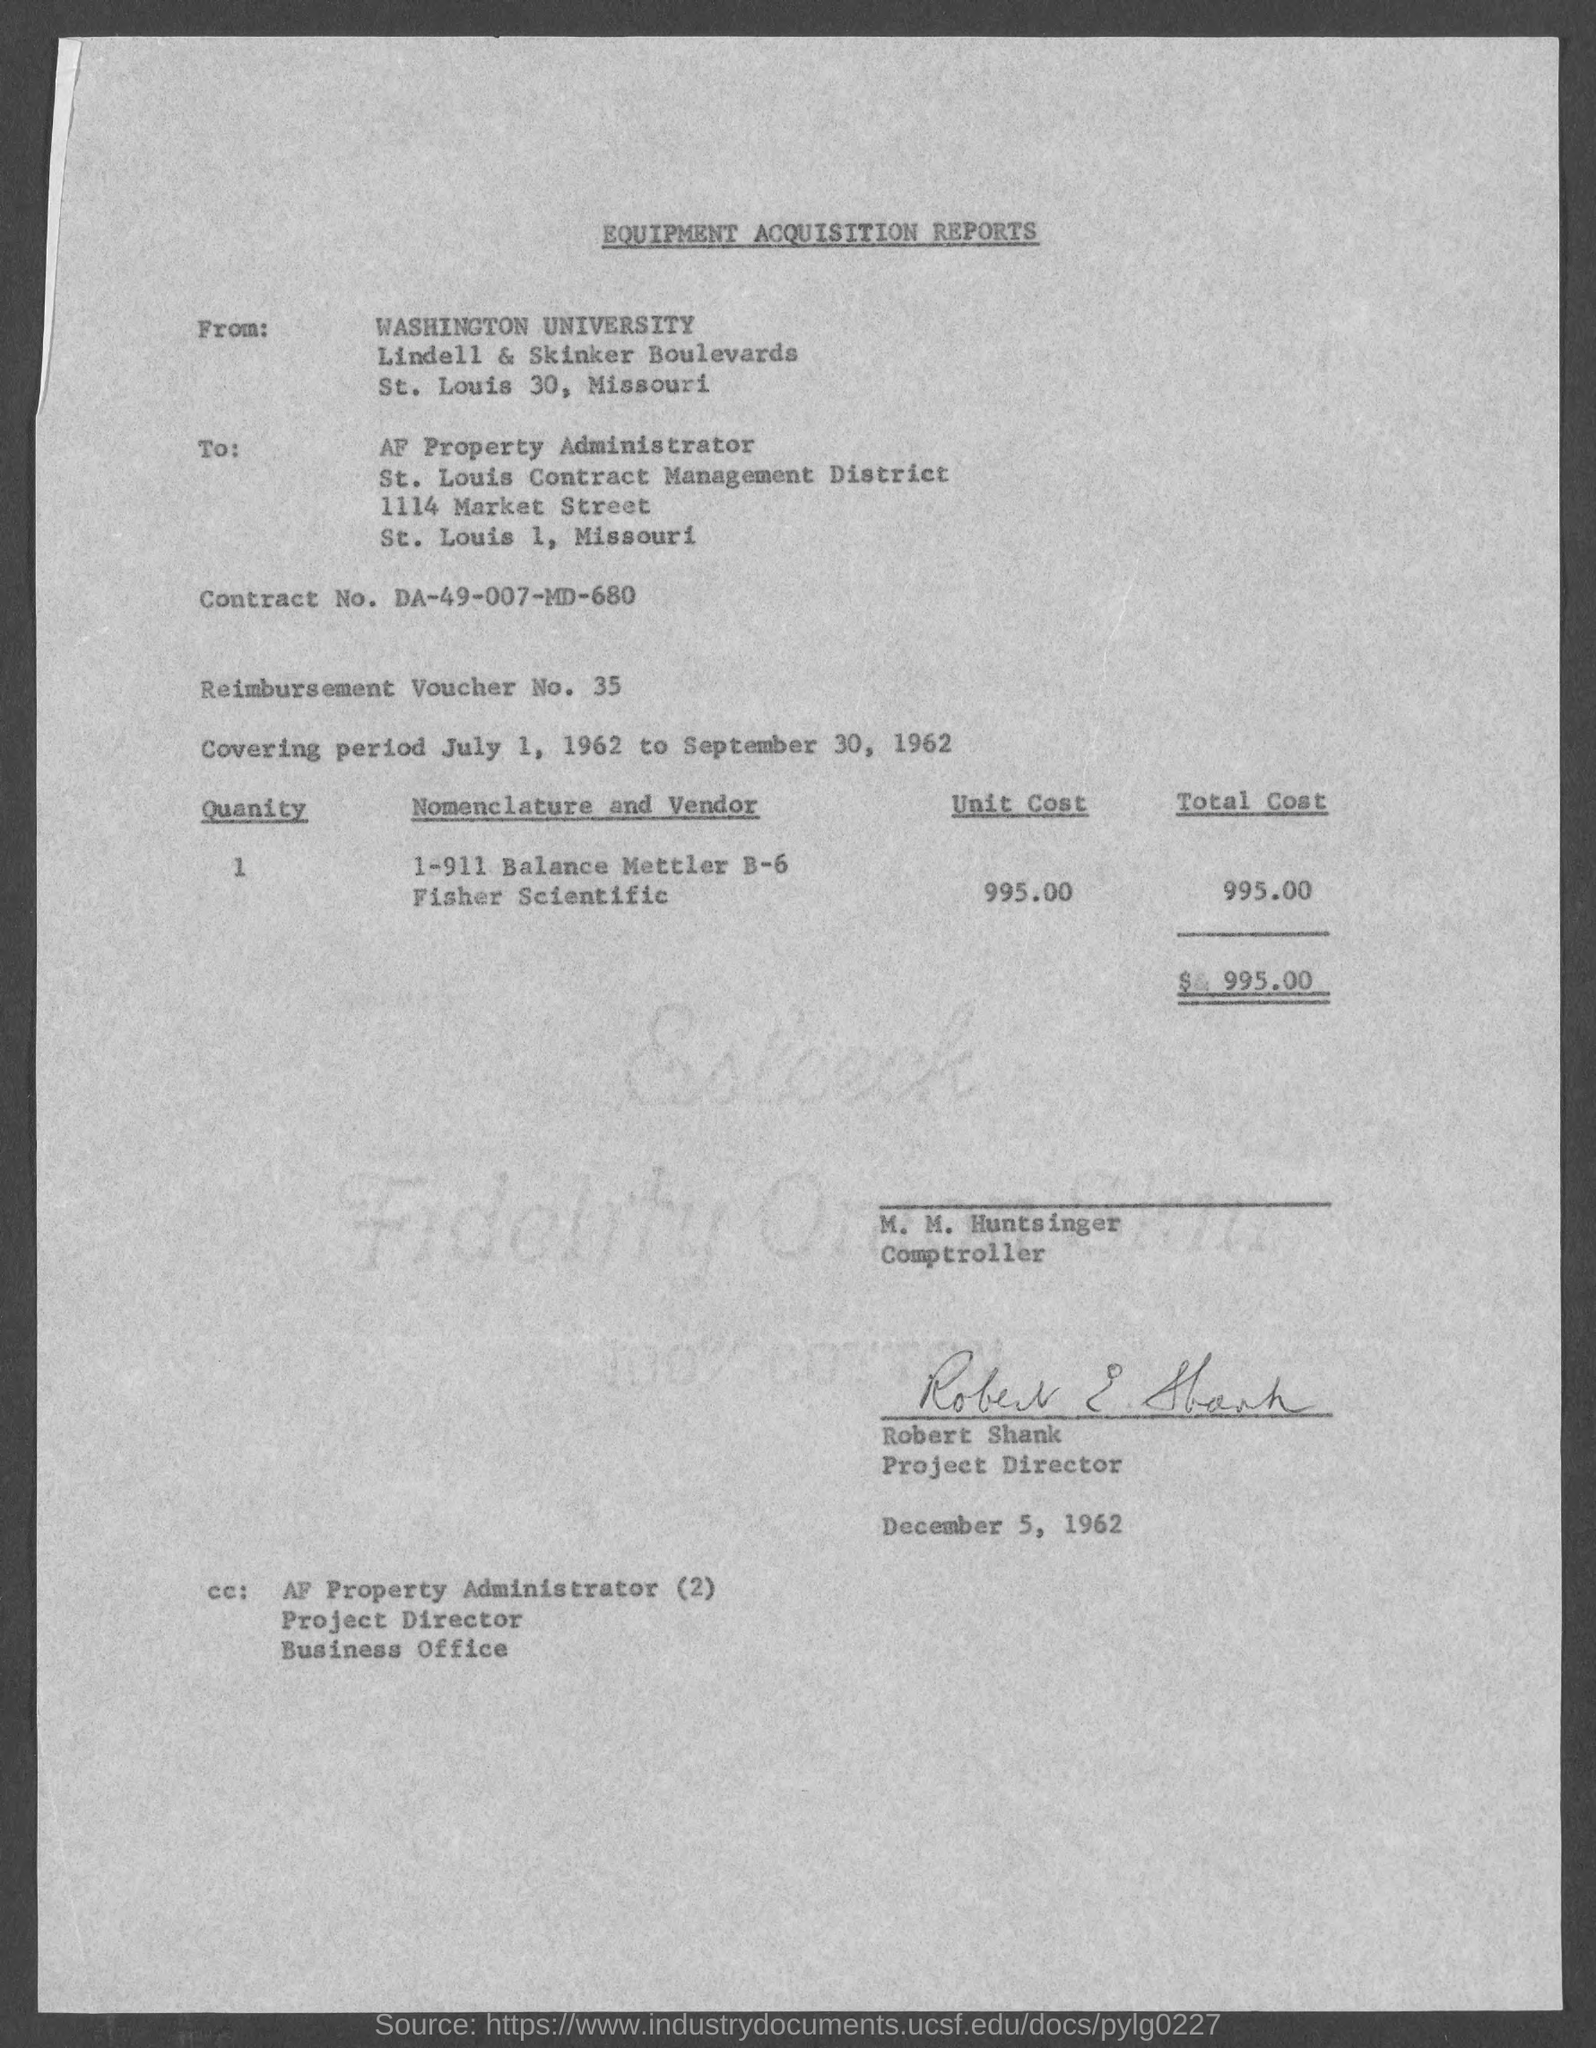Give some essential details in this illustration. The total cost mentioned on the given page is $995.00. The covering period mentioned in the given report is from July 1, 1962 to September 30, 1962. The unit cost mentioned in the given report is 995.00. The quantity mentioned in the given report is 1. The report was sent from Washington University. 